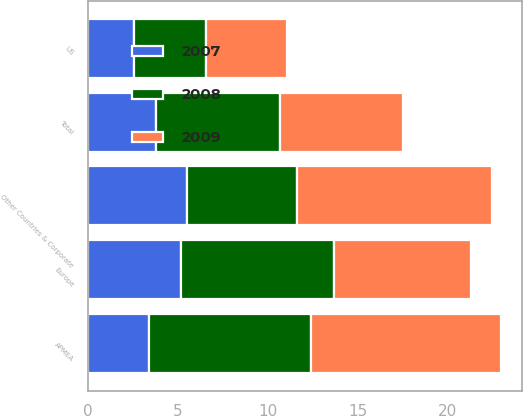<chart> <loc_0><loc_0><loc_500><loc_500><stacked_bar_chart><ecel><fcel>US<fcel>Europe<fcel>APMEA<fcel>Other Countries & Corporate<fcel>Total<nl><fcel>2007<fcel>2.6<fcel>5.2<fcel>3.4<fcel>5.5<fcel>3.8<nl><fcel>2008<fcel>4<fcel>8.5<fcel>9<fcel>6.15<fcel>6.9<nl><fcel>2009<fcel>4.5<fcel>7.6<fcel>10.6<fcel>10.8<fcel>6.8<nl></chart> 